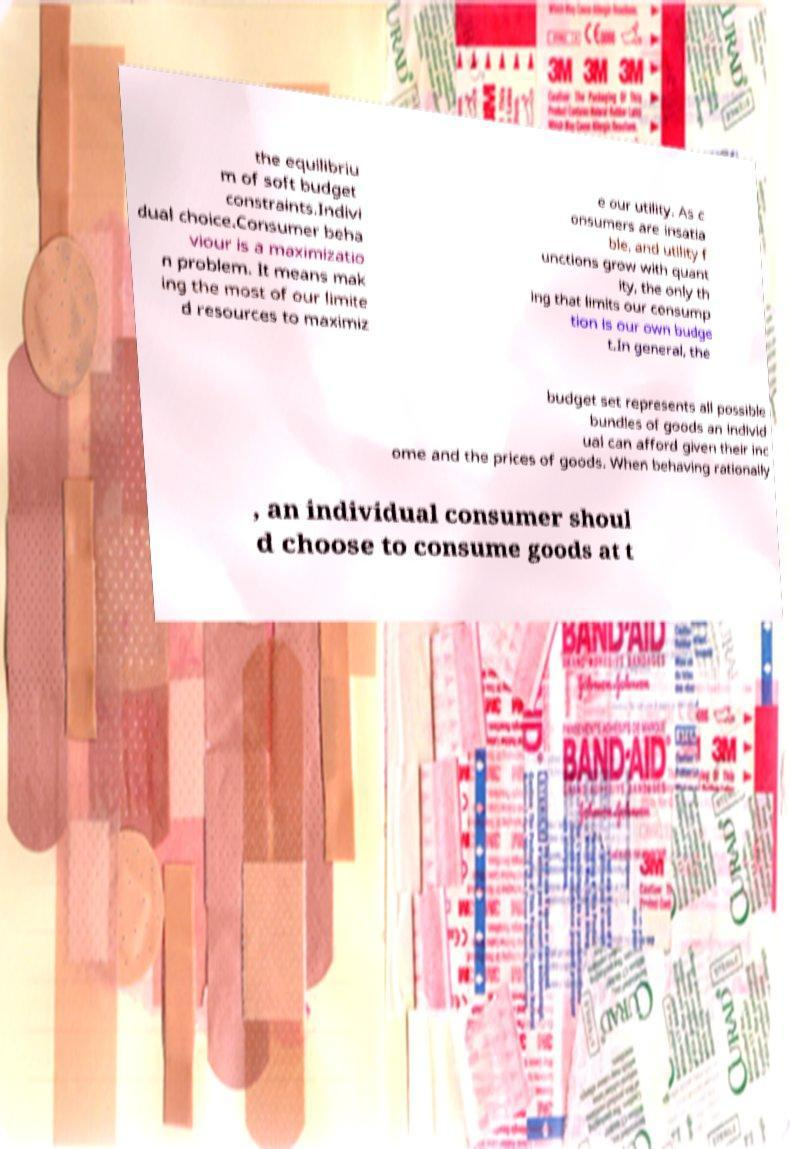Can you read and provide the text displayed in the image?This photo seems to have some interesting text. Can you extract and type it out for me? the equilibriu m of soft budget constraints.Indivi dual choice.Consumer beha viour is a maximizatio n problem. It means mak ing the most of our limite d resources to maximiz e our utility. As c onsumers are insatia ble, and utility f unctions grow with quant ity, the only th ing that limits our consump tion is our own budge t.In general, the budget set represents all possible bundles of goods an individ ual can afford given their inc ome and the prices of goods. When behaving rationally , an individual consumer shoul d choose to consume goods at t 